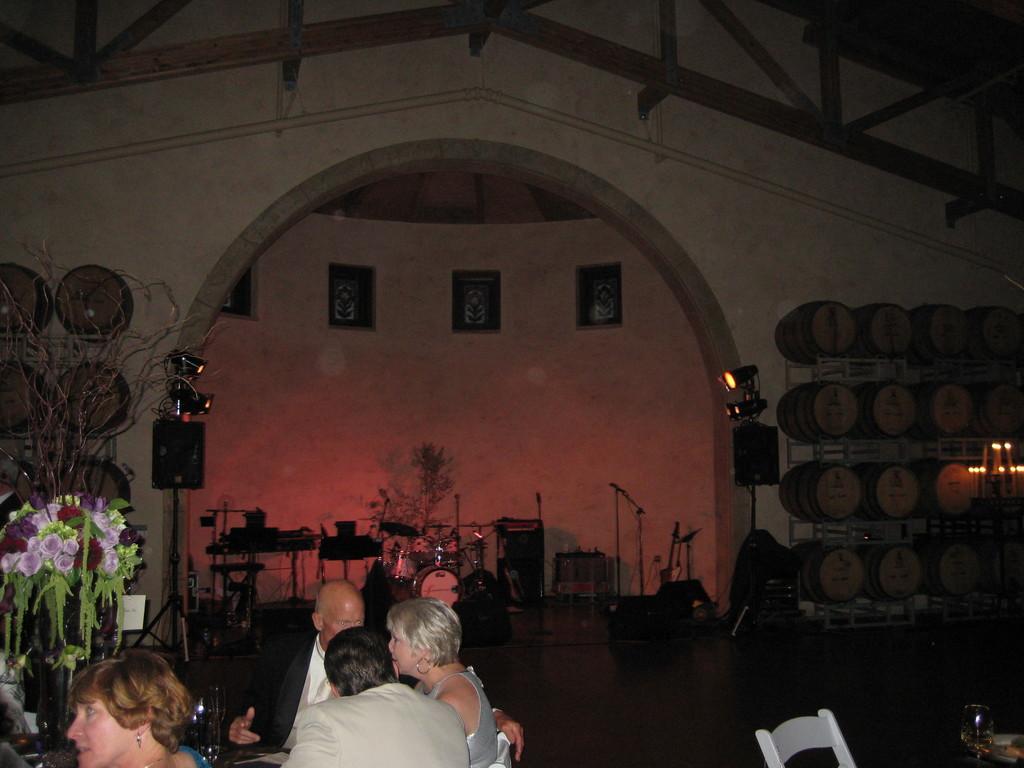Could you give a brief overview of what you see in this image? In the picture we can see some people near the desk, on it we can see some glasses and flower vase with some flowers in it and behind them, we can see a chair and a table and in the background, we can see an orchestra and some musical instruments are placed and beside to it, we can see some lights to the stand and beside it we can see some racks with drums and to the ceiling we can see some wooden sticks. 